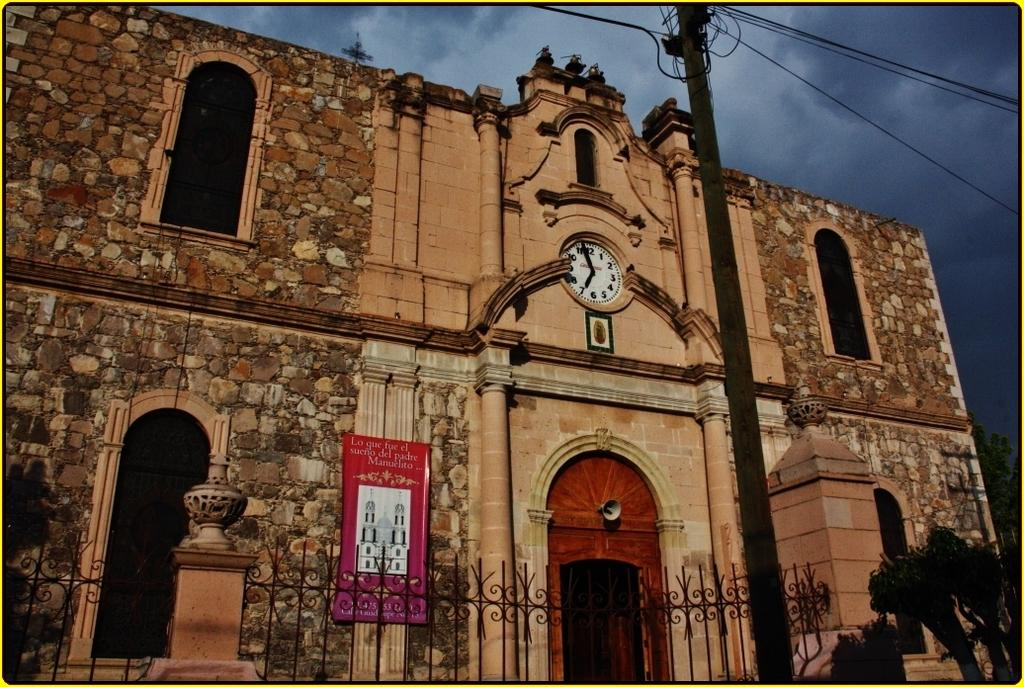Provide a one-sentence caption for the provided image. A large brick and stone building with a clock on the front that states that it is nearly 7 o'clock. 